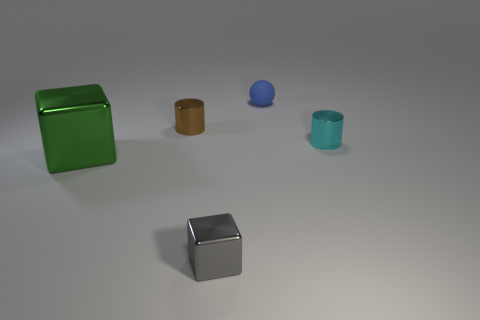Add 2 brown metal cylinders. How many objects exist? 7 Subtract all cylinders. How many objects are left? 3 Subtract 0 blue cylinders. How many objects are left? 5 Subtract all big yellow rubber blocks. Subtract all tiny cubes. How many objects are left? 4 Add 5 blue matte spheres. How many blue matte spheres are left? 6 Add 2 tiny shiny cylinders. How many tiny shiny cylinders exist? 4 